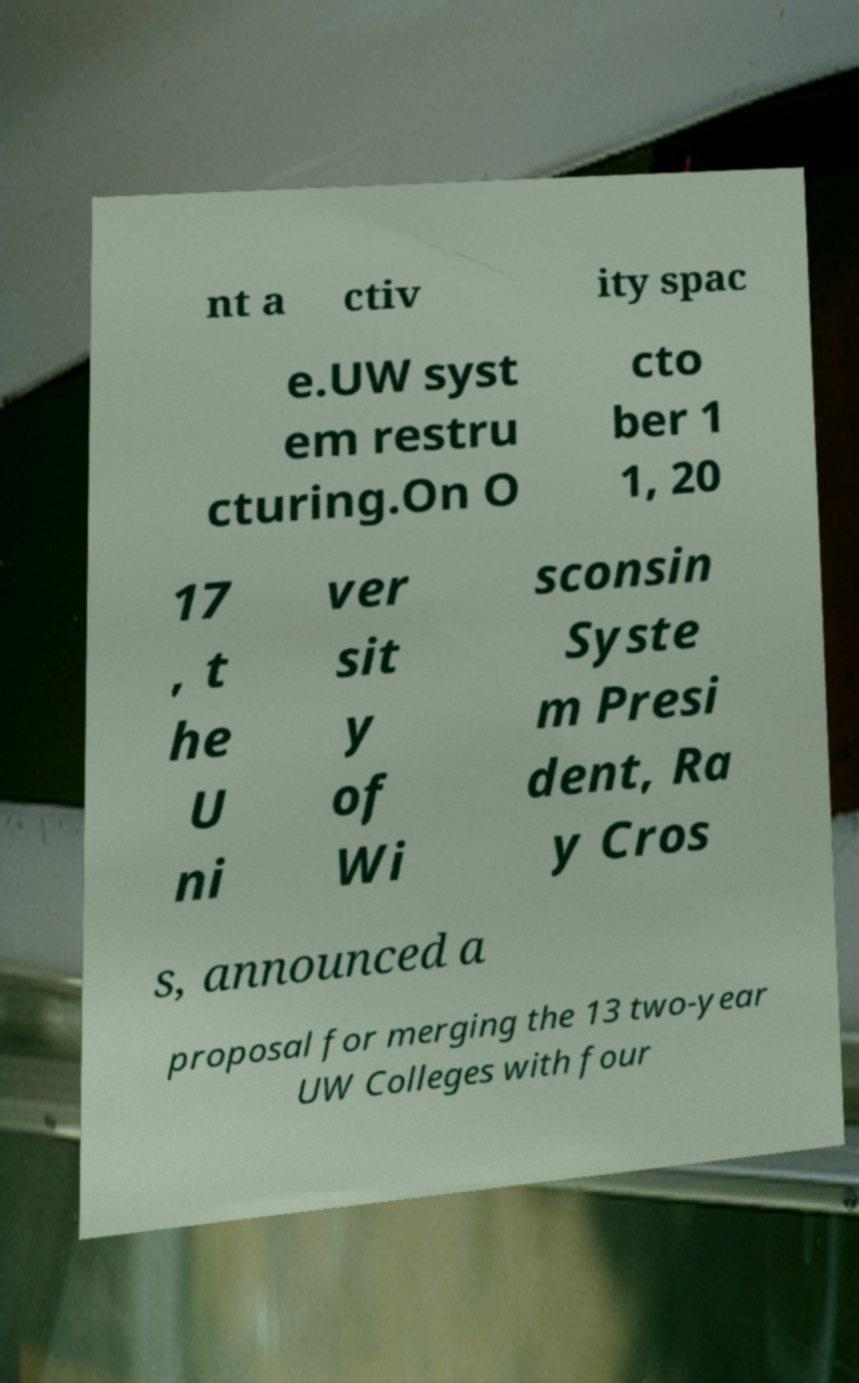Could you assist in decoding the text presented in this image and type it out clearly? nt a ctiv ity spac e.UW syst em restru cturing.On O cto ber 1 1, 20 17 , t he U ni ver sit y of Wi sconsin Syste m Presi dent, Ra y Cros s, announced a proposal for merging the 13 two-year UW Colleges with four 